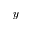Convert formula to latex. <formula><loc_0><loc_0><loc_500><loc_500>y</formula> 